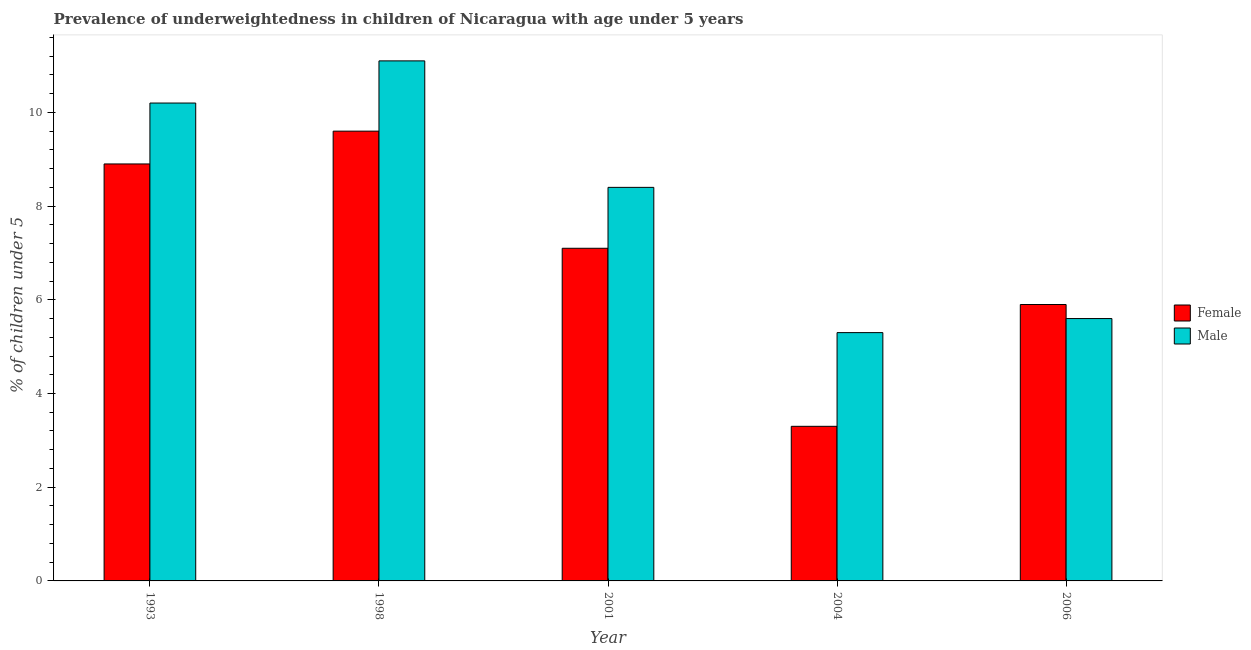How many bars are there on the 3rd tick from the left?
Offer a terse response. 2. How many bars are there on the 4th tick from the right?
Ensure brevity in your answer.  2. What is the label of the 5th group of bars from the left?
Your answer should be compact. 2006. What is the percentage of underweighted female children in 1998?
Your answer should be compact. 9.6. Across all years, what is the maximum percentage of underweighted female children?
Your answer should be very brief. 9.6. Across all years, what is the minimum percentage of underweighted male children?
Your answer should be very brief. 5.3. In which year was the percentage of underweighted female children maximum?
Provide a short and direct response. 1998. In which year was the percentage of underweighted male children minimum?
Ensure brevity in your answer.  2004. What is the total percentage of underweighted male children in the graph?
Offer a very short reply. 40.6. What is the difference between the percentage of underweighted male children in 1998 and that in 2001?
Ensure brevity in your answer.  2.7. What is the difference between the percentage of underweighted male children in 2006 and the percentage of underweighted female children in 1993?
Your answer should be very brief. -4.6. What is the average percentage of underweighted male children per year?
Your response must be concise. 8.12. What is the ratio of the percentage of underweighted male children in 1998 to that in 2006?
Offer a terse response. 1.98. Is the percentage of underweighted female children in 1993 less than that in 1998?
Offer a terse response. Yes. Is the difference between the percentage of underweighted female children in 1993 and 2001 greater than the difference between the percentage of underweighted male children in 1993 and 2001?
Your response must be concise. No. What is the difference between the highest and the second highest percentage of underweighted female children?
Ensure brevity in your answer.  0.7. What is the difference between the highest and the lowest percentage of underweighted female children?
Keep it short and to the point. 6.3. In how many years, is the percentage of underweighted female children greater than the average percentage of underweighted female children taken over all years?
Your answer should be very brief. 3. What does the 2nd bar from the right in 2004 represents?
Give a very brief answer. Female. Are all the bars in the graph horizontal?
Your answer should be compact. No. How many years are there in the graph?
Your response must be concise. 5. Are the values on the major ticks of Y-axis written in scientific E-notation?
Keep it short and to the point. No. How many legend labels are there?
Your answer should be very brief. 2. What is the title of the graph?
Give a very brief answer. Prevalence of underweightedness in children of Nicaragua with age under 5 years. What is the label or title of the X-axis?
Keep it short and to the point. Year. What is the label or title of the Y-axis?
Give a very brief answer.  % of children under 5. What is the  % of children under 5 of Female in 1993?
Give a very brief answer. 8.9. What is the  % of children under 5 of Male in 1993?
Provide a short and direct response. 10.2. What is the  % of children under 5 of Female in 1998?
Keep it short and to the point. 9.6. What is the  % of children under 5 of Male in 1998?
Give a very brief answer. 11.1. What is the  % of children under 5 in Female in 2001?
Your answer should be very brief. 7.1. What is the  % of children under 5 in Male in 2001?
Offer a very short reply. 8.4. What is the  % of children under 5 in Female in 2004?
Your answer should be compact. 3.3. What is the  % of children under 5 in Male in 2004?
Make the answer very short. 5.3. What is the  % of children under 5 in Female in 2006?
Provide a short and direct response. 5.9. What is the  % of children under 5 of Male in 2006?
Provide a short and direct response. 5.6. Across all years, what is the maximum  % of children under 5 in Female?
Offer a very short reply. 9.6. Across all years, what is the maximum  % of children under 5 of Male?
Provide a succinct answer. 11.1. Across all years, what is the minimum  % of children under 5 in Female?
Your answer should be very brief. 3.3. Across all years, what is the minimum  % of children under 5 of Male?
Give a very brief answer. 5.3. What is the total  % of children under 5 in Female in the graph?
Ensure brevity in your answer.  34.8. What is the total  % of children under 5 of Male in the graph?
Ensure brevity in your answer.  40.6. What is the difference between the  % of children under 5 of Male in 1998 and that in 2001?
Keep it short and to the point. 2.7. What is the difference between the  % of children under 5 in Male in 1998 and that in 2004?
Provide a succinct answer. 5.8. What is the difference between the  % of children under 5 in Female in 1998 and that in 2006?
Offer a terse response. 3.7. What is the difference between the  % of children under 5 in Male in 2001 and that in 2004?
Provide a short and direct response. 3.1. What is the difference between the  % of children under 5 in Female in 2004 and that in 2006?
Offer a very short reply. -2.6. What is the difference between the  % of children under 5 in Male in 2004 and that in 2006?
Keep it short and to the point. -0.3. What is the difference between the  % of children under 5 in Female in 1993 and the  % of children under 5 in Male in 2004?
Ensure brevity in your answer.  3.6. What is the difference between the  % of children under 5 of Female in 1998 and the  % of children under 5 of Male in 2004?
Make the answer very short. 4.3. What is the difference between the  % of children under 5 of Female in 1998 and the  % of children under 5 of Male in 2006?
Provide a succinct answer. 4. What is the difference between the  % of children under 5 of Female in 2004 and the  % of children under 5 of Male in 2006?
Ensure brevity in your answer.  -2.3. What is the average  % of children under 5 in Female per year?
Your answer should be compact. 6.96. What is the average  % of children under 5 of Male per year?
Keep it short and to the point. 8.12. In the year 1993, what is the difference between the  % of children under 5 in Female and  % of children under 5 in Male?
Give a very brief answer. -1.3. In the year 2004, what is the difference between the  % of children under 5 of Female and  % of children under 5 of Male?
Provide a short and direct response. -2. In the year 2006, what is the difference between the  % of children under 5 of Female and  % of children under 5 of Male?
Your answer should be very brief. 0.3. What is the ratio of the  % of children under 5 in Female in 1993 to that in 1998?
Provide a short and direct response. 0.93. What is the ratio of the  % of children under 5 in Male in 1993 to that in 1998?
Your answer should be very brief. 0.92. What is the ratio of the  % of children under 5 in Female in 1993 to that in 2001?
Provide a short and direct response. 1.25. What is the ratio of the  % of children under 5 in Male in 1993 to that in 2001?
Make the answer very short. 1.21. What is the ratio of the  % of children under 5 in Female in 1993 to that in 2004?
Provide a short and direct response. 2.7. What is the ratio of the  % of children under 5 in Male in 1993 to that in 2004?
Your answer should be compact. 1.92. What is the ratio of the  % of children under 5 of Female in 1993 to that in 2006?
Offer a very short reply. 1.51. What is the ratio of the  % of children under 5 in Male in 1993 to that in 2006?
Keep it short and to the point. 1.82. What is the ratio of the  % of children under 5 of Female in 1998 to that in 2001?
Your answer should be compact. 1.35. What is the ratio of the  % of children under 5 of Male in 1998 to that in 2001?
Keep it short and to the point. 1.32. What is the ratio of the  % of children under 5 of Female in 1998 to that in 2004?
Offer a terse response. 2.91. What is the ratio of the  % of children under 5 of Male in 1998 to that in 2004?
Your answer should be compact. 2.09. What is the ratio of the  % of children under 5 of Female in 1998 to that in 2006?
Keep it short and to the point. 1.63. What is the ratio of the  % of children under 5 in Male in 1998 to that in 2006?
Your answer should be compact. 1.98. What is the ratio of the  % of children under 5 of Female in 2001 to that in 2004?
Provide a succinct answer. 2.15. What is the ratio of the  % of children under 5 of Male in 2001 to that in 2004?
Make the answer very short. 1.58. What is the ratio of the  % of children under 5 of Female in 2001 to that in 2006?
Ensure brevity in your answer.  1.2. What is the ratio of the  % of children under 5 of Female in 2004 to that in 2006?
Give a very brief answer. 0.56. What is the ratio of the  % of children under 5 of Male in 2004 to that in 2006?
Keep it short and to the point. 0.95. What is the difference between the highest and the second highest  % of children under 5 of Female?
Offer a terse response. 0.7. What is the difference between the highest and the lowest  % of children under 5 of Female?
Keep it short and to the point. 6.3. 